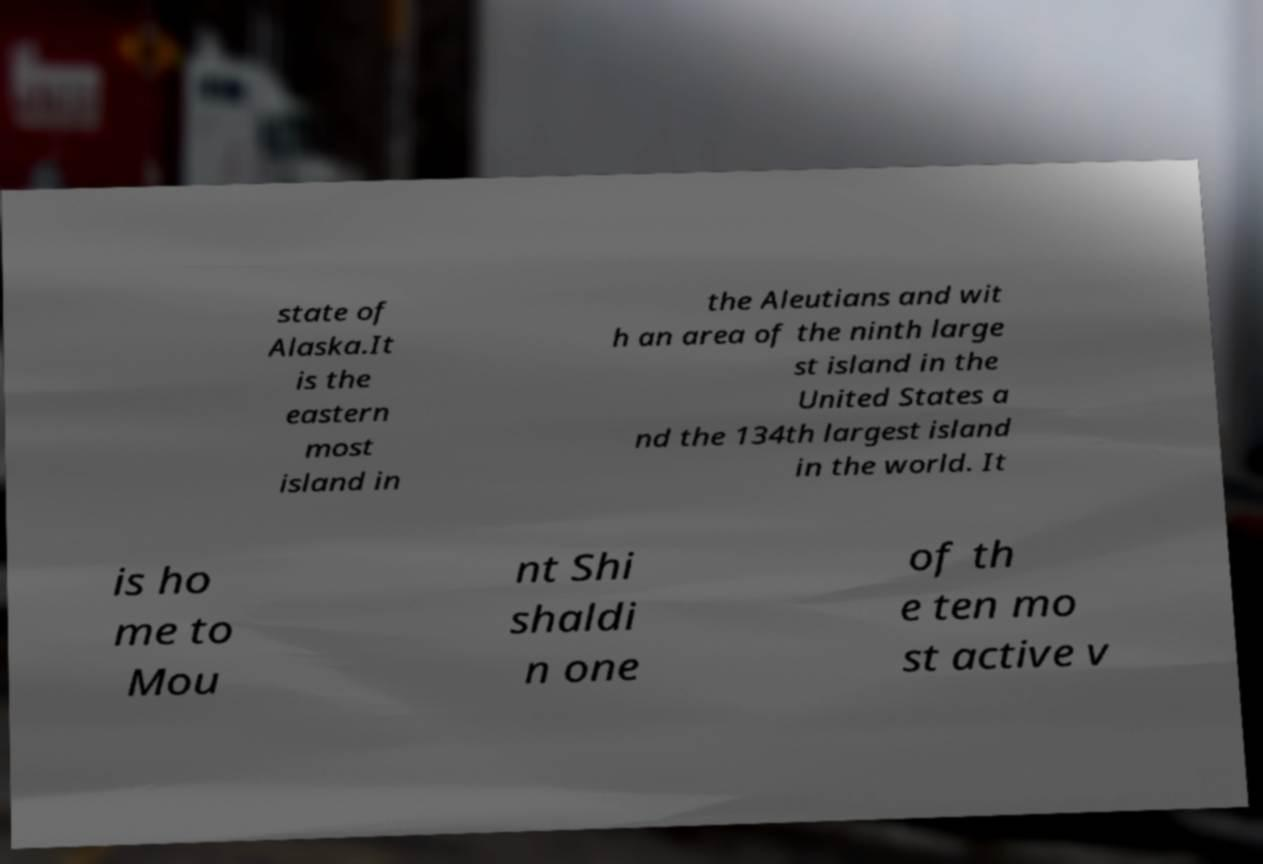I need the written content from this picture converted into text. Can you do that? state of Alaska.It is the eastern most island in the Aleutians and wit h an area of the ninth large st island in the United States a nd the 134th largest island in the world. It is ho me to Mou nt Shi shaldi n one of th e ten mo st active v 